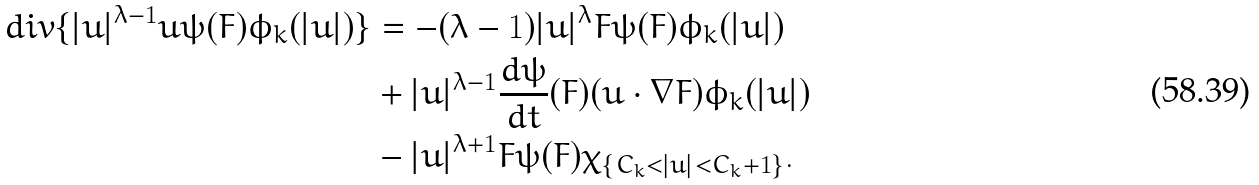<formula> <loc_0><loc_0><loc_500><loc_500>d i v \{ | u | ^ { \lambda - 1 } u \psi ( F ) \phi _ { k } ( | u | ) \} & = - ( \lambda - 1 ) | u | ^ { \lambda } F \psi ( F ) \phi _ { k } ( | u | ) \\ & + | u | ^ { \lambda - 1 } \frac { d \psi } { d t } ( F ) ( u \cdot \nabla F ) \phi _ { k } ( | u | ) \\ & - | u | ^ { \lambda + 1 } F \psi ( F ) \chi _ { \{ C _ { k } < | u | < C _ { k } + 1 \} } .</formula> 